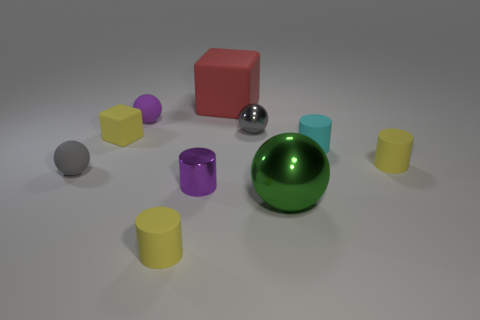There is a purple metal thing that is the same size as the cyan rubber cylinder; what shape is it?
Offer a terse response. Cylinder. Are there any other big matte objects that have the same shape as the gray matte object?
Your answer should be compact. No. Is the material of the tiny cyan cylinder the same as the tiny cylinder to the left of the small purple cylinder?
Your answer should be compact. Yes. Are there any other balls of the same color as the tiny metal ball?
Your answer should be compact. Yes. How many other things are there of the same material as the purple sphere?
Your response must be concise. 6. Does the tiny shiny ball have the same color as the tiny matte sphere that is in front of the gray metal thing?
Ensure brevity in your answer.  Yes. Are there more cubes behind the big red block than cyan cylinders?
Give a very brief answer. No. There is a small gray object left of the purple sphere that is on the left side of the tiny metallic cylinder; how many tiny shiny things are behind it?
Your answer should be compact. 1. There is a big green object in front of the small cyan object; is it the same shape as the gray metal thing?
Offer a terse response. Yes. There is a small yellow cylinder that is left of the large green shiny sphere; what is its material?
Provide a succinct answer. Rubber. 